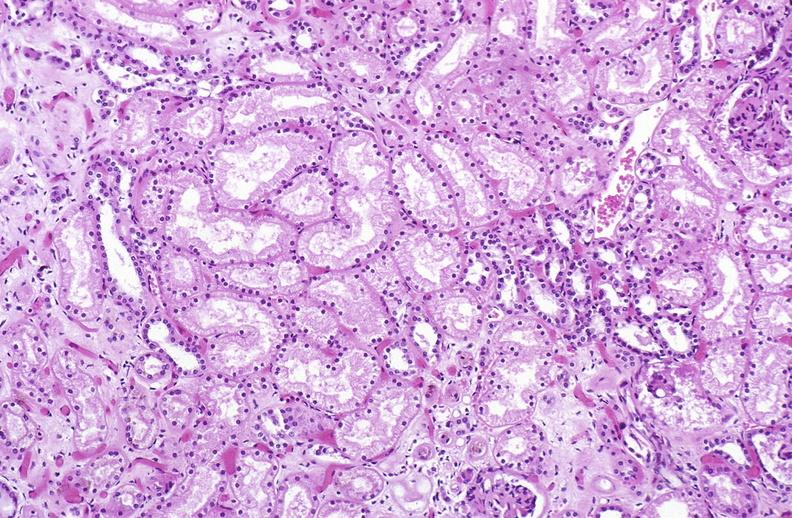does this image show atn acute tubular necrosis?
Answer the question using a single word or phrase. Yes 